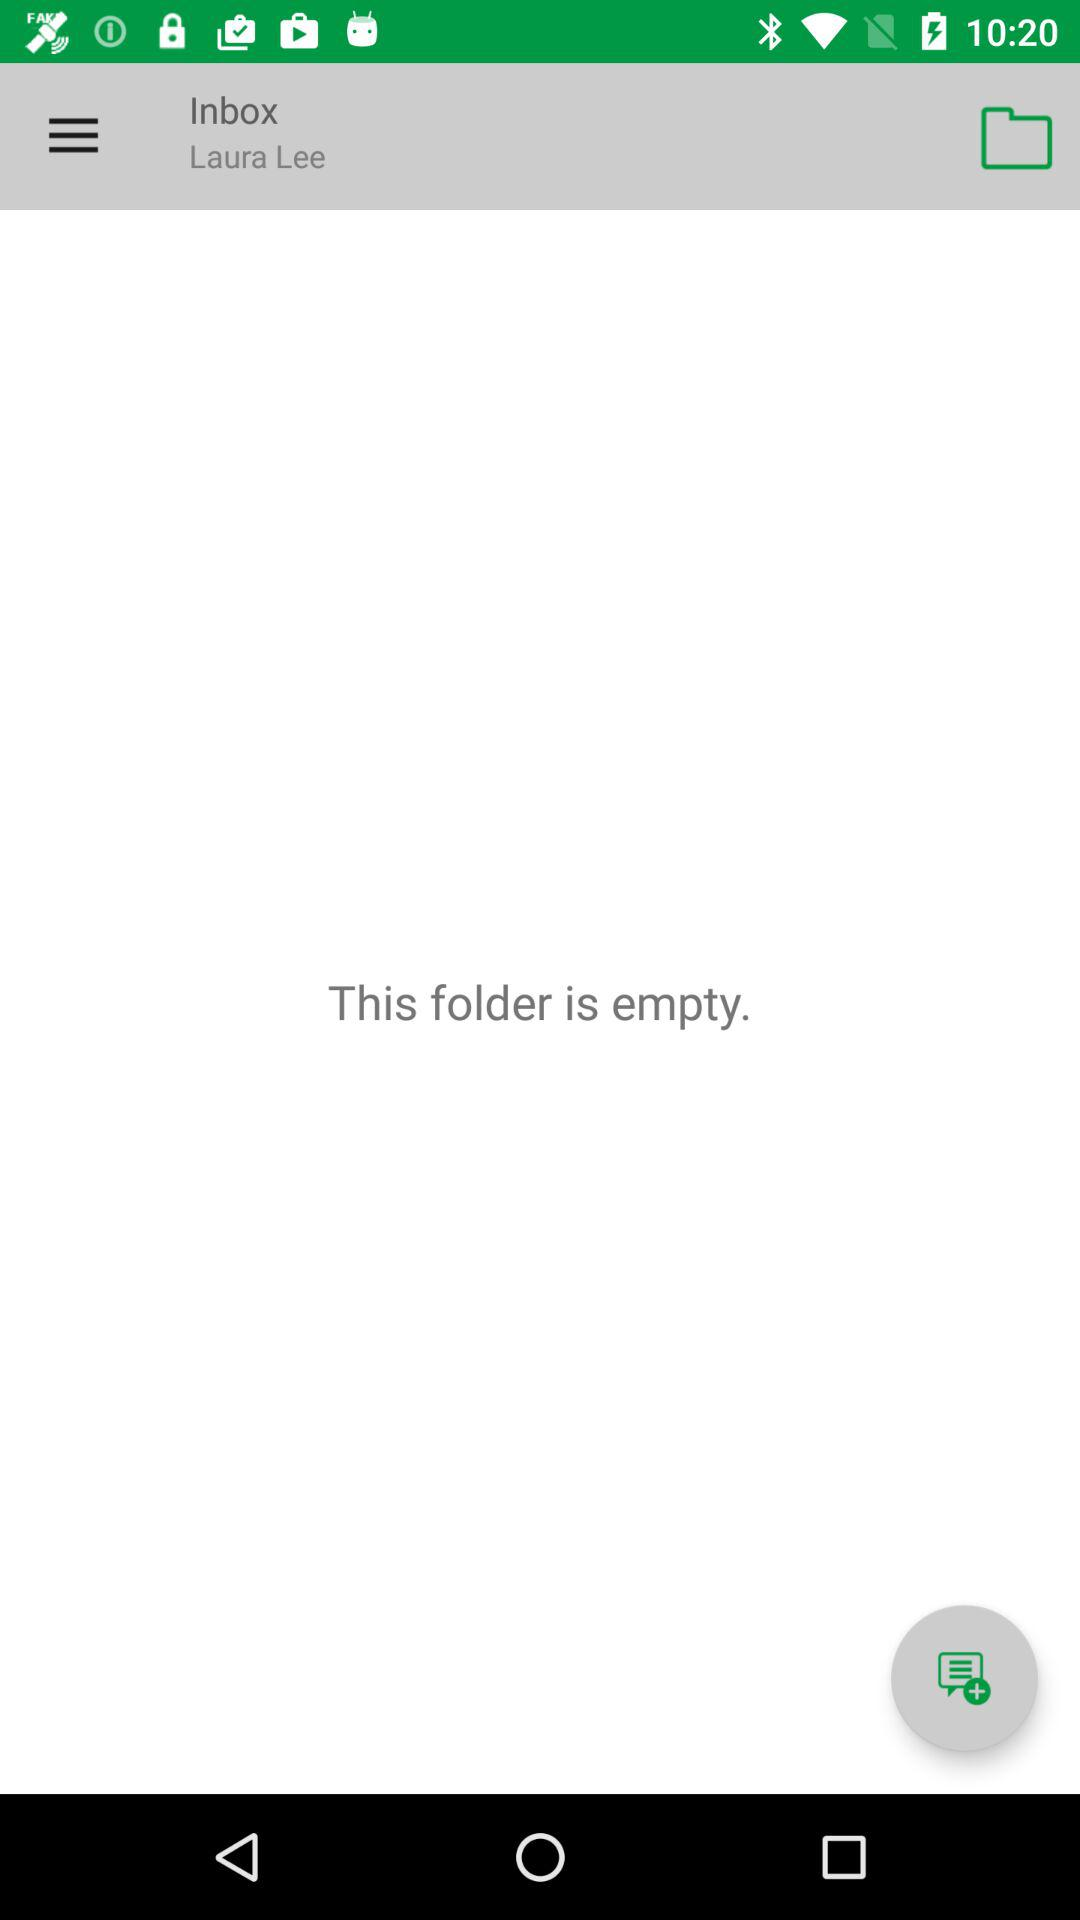What is the mentioned name? The mentioned name is Laura Lee. 